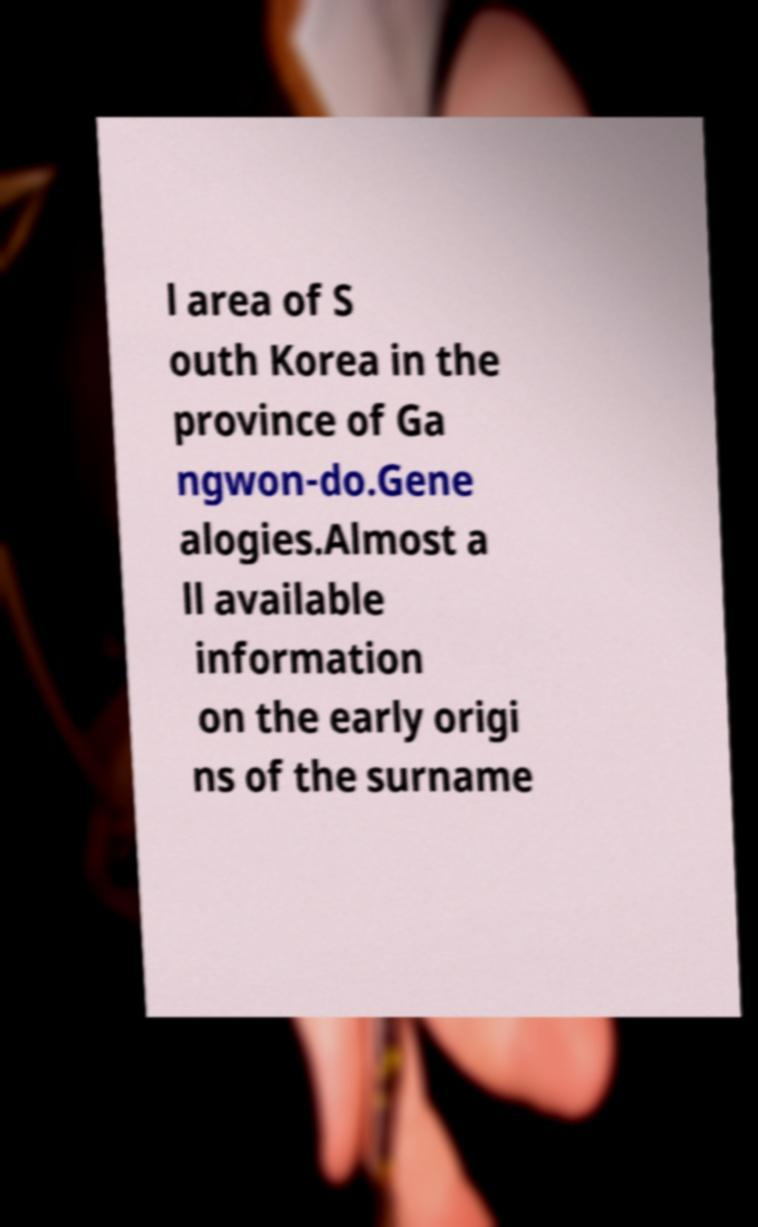Could you assist in decoding the text presented in this image and type it out clearly? l area of S outh Korea in the province of Ga ngwon-do.Gene alogies.Almost a ll available information on the early origi ns of the surname 